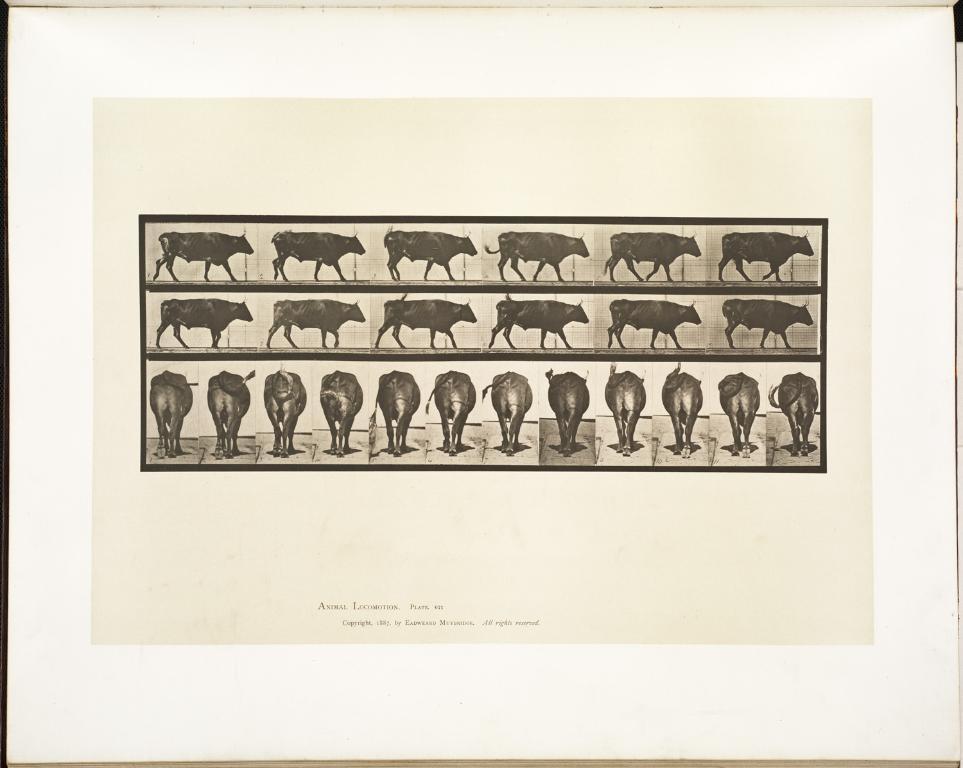Could you give a brief overview of what you see in this image? In this image we can see a poster. In this poster there are different pictures of an animal. Something is written at the bottom of the image. 